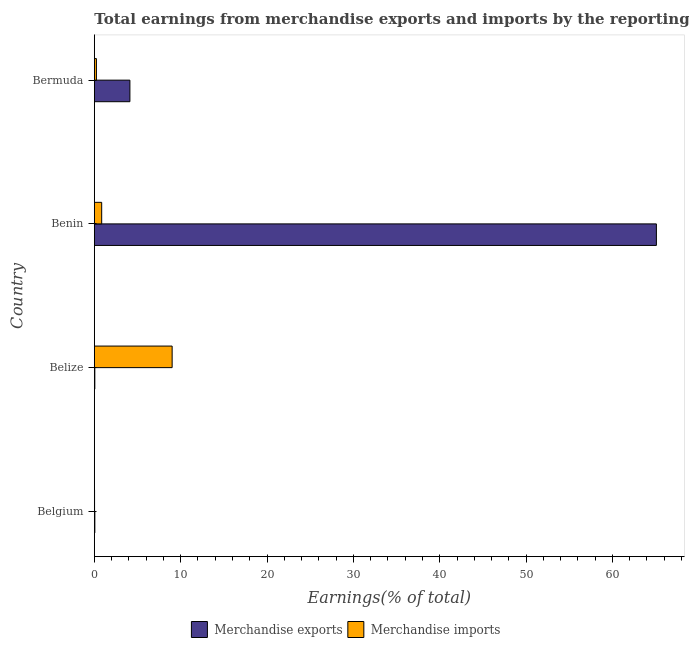How many different coloured bars are there?
Give a very brief answer. 2. How many bars are there on the 4th tick from the top?
Offer a terse response. 2. How many bars are there on the 3rd tick from the bottom?
Offer a terse response. 2. What is the label of the 2nd group of bars from the top?
Give a very brief answer. Benin. What is the earnings from merchandise exports in Benin?
Offer a very short reply. 65.09. Across all countries, what is the maximum earnings from merchandise exports?
Keep it short and to the point. 65.09. Across all countries, what is the minimum earnings from merchandise imports?
Ensure brevity in your answer.  0.03. In which country was the earnings from merchandise imports maximum?
Make the answer very short. Belize. In which country was the earnings from merchandise exports minimum?
Give a very brief answer. Belize. What is the total earnings from merchandise imports in the graph?
Ensure brevity in your answer.  10.13. What is the difference between the earnings from merchandise imports in Belize and that in Bermuda?
Provide a short and direct response. 8.77. What is the difference between the earnings from merchandise imports in Bermuda and the earnings from merchandise exports in Belize?
Make the answer very short. 0.19. What is the average earnings from merchandise exports per country?
Keep it short and to the point. 17.33. What is the difference between the earnings from merchandise imports and earnings from merchandise exports in Benin?
Provide a succinct answer. -64.24. What is the ratio of the earnings from merchandise exports in Belize to that in Bermuda?
Give a very brief answer. 0.01. What is the difference between the highest and the second highest earnings from merchandise exports?
Make the answer very short. 60.97. What is the difference between the highest and the lowest earnings from merchandise imports?
Keep it short and to the point. 8.98. What does the 2nd bar from the top in Benin represents?
Ensure brevity in your answer.  Merchandise exports. How many bars are there?
Make the answer very short. 8. Are all the bars in the graph horizontal?
Offer a very short reply. Yes. How many countries are there in the graph?
Keep it short and to the point. 4. What is the difference between two consecutive major ticks on the X-axis?
Keep it short and to the point. 10. Are the values on the major ticks of X-axis written in scientific E-notation?
Keep it short and to the point. No. Does the graph contain any zero values?
Offer a terse response. No. How many legend labels are there?
Keep it short and to the point. 2. What is the title of the graph?
Offer a very short reply. Total earnings from merchandise exports and imports by the reporting economy(residual) in 2001. Does "Female population" appear as one of the legend labels in the graph?
Your answer should be very brief. No. What is the label or title of the X-axis?
Your answer should be compact. Earnings(% of total). What is the Earnings(% of total) of Merchandise exports in Belgium?
Your response must be concise. 0.06. What is the Earnings(% of total) of Merchandise imports in Belgium?
Offer a terse response. 0.03. What is the Earnings(% of total) of Merchandise exports in Belize?
Provide a short and direct response. 0.06. What is the Earnings(% of total) of Merchandise imports in Belize?
Offer a very short reply. 9.01. What is the Earnings(% of total) of Merchandise exports in Benin?
Provide a succinct answer. 65.09. What is the Earnings(% of total) in Merchandise imports in Benin?
Ensure brevity in your answer.  0.85. What is the Earnings(% of total) of Merchandise exports in Bermuda?
Ensure brevity in your answer.  4.12. What is the Earnings(% of total) of Merchandise imports in Bermuda?
Keep it short and to the point. 0.24. Across all countries, what is the maximum Earnings(% of total) in Merchandise exports?
Your answer should be very brief. 65.09. Across all countries, what is the maximum Earnings(% of total) of Merchandise imports?
Keep it short and to the point. 9.01. Across all countries, what is the minimum Earnings(% of total) of Merchandise exports?
Your answer should be very brief. 0.06. Across all countries, what is the minimum Earnings(% of total) in Merchandise imports?
Give a very brief answer. 0.03. What is the total Earnings(% of total) in Merchandise exports in the graph?
Your answer should be compact. 69.32. What is the total Earnings(% of total) in Merchandise imports in the graph?
Your response must be concise. 10.13. What is the difference between the Earnings(% of total) of Merchandise exports in Belgium and that in Belize?
Your answer should be very brief. 0. What is the difference between the Earnings(% of total) in Merchandise imports in Belgium and that in Belize?
Offer a terse response. -8.98. What is the difference between the Earnings(% of total) of Merchandise exports in Belgium and that in Benin?
Your answer should be compact. -65.03. What is the difference between the Earnings(% of total) of Merchandise imports in Belgium and that in Benin?
Ensure brevity in your answer.  -0.82. What is the difference between the Earnings(% of total) in Merchandise exports in Belgium and that in Bermuda?
Your response must be concise. -4.06. What is the difference between the Earnings(% of total) of Merchandise imports in Belgium and that in Bermuda?
Provide a short and direct response. -0.22. What is the difference between the Earnings(% of total) of Merchandise exports in Belize and that in Benin?
Keep it short and to the point. -65.03. What is the difference between the Earnings(% of total) in Merchandise imports in Belize and that in Benin?
Keep it short and to the point. 8.16. What is the difference between the Earnings(% of total) in Merchandise exports in Belize and that in Bermuda?
Your answer should be compact. -4.06. What is the difference between the Earnings(% of total) in Merchandise imports in Belize and that in Bermuda?
Provide a succinct answer. 8.77. What is the difference between the Earnings(% of total) in Merchandise exports in Benin and that in Bermuda?
Offer a terse response. 60.97. What is the difference between the Earnings(% of total) of Merchandise imports in Benin and that in Bermuda?
Your answer should be very brief. 0.61. What is the difference between the Earnings(% of total) in Merchandise exports in Belgium and the Earnings(% of total) in Merchandise imports in Belize?
Provide a short and direct response. -8.95. What is the difference between the Earnings(% of total) in Merchandise exports in Belgium and the Earnings(% of total) in Merchandise imports in Benin?
Ensure brevity in your answer.  -0.79. What is the difference between the Earnings(% of total) in Merchandise exports in Belgium and the Earnings(% of total) in Merchandise imports in Bermuda?
Your answer should be very brief. -0.18. What is the difference between the Earnings(% of total) in Merchandise exports in Belize and the Earnings(% of total) in Merchandise imports in Benin?
Offer a terse response. -0.79. What is the difference between the Earnings(% of total) in Merchandise exports in Belize and the Earnings(% of total) in Merchandise imports in Bermuda?
Offer a terse response. -0.19. What is the difference between the Earnings(% of total) of Merchandise exports in Benin and the Earnings(% of total) of Merchandise imports in Bermuda?
Offer a terse response. 64.85. What is the average Earnings(% of total) in Merchandise exports per country?
Give a very brief answer. 17.33. What is the average Earnings(% of total) in Merchandise imports per country?
Give a very brief answer. 2.53. What is the difference between the Earnings(% of total) of Merchandise exports and Earnings(% of total) of Merchandise imports in Belgium?
Ensure brevity in your answer.  0.03. What is the difference between the Earnings(% of total) in Merchandise exports and Earnings(% of total) in Merchandise imports in Belize?
Provide a short and direct response. -8.95. What is the difference between the Earnings(% of total) of Merchandise exports and Earnings(% of total) of Merchandise imports in Benin?
Offer a very short reply. 64.24. What is the difference between the Earnings(% of total) in Merchandise exports and Earnings(% of total) in Merchandise imports in Bermuda?
Provide a short and direct response. 3.88. What is the ratio of the Earnings(% of total) of Merchandise exports in Belgium to that in Belize?
Provide a short and direct response. 1.03. What is the ratio of the Earnings(% of total) of Merchandise imports in Belgium to that in Belize?
Your response must be concise. 0. What is the ratio of the Earnings(% of total) of Merchandise exports in Belgium to that in Benin?
Your answer should be compact. 0. What is the ratio of the Earnings(% of total) of Merchandise imports in Belgium to that in Benin?
Provide a short and direct response. 0.03. What is the ratio of the Earnings(% of total) in Merchandise exports in Belgium to that in Bermuda?
Ensure brevity in your answer.  0.01. What is the ratio of the Earnings(% of total) in Merchandise imports in Belgium to that in Bermuda?
Your response must be concise. 0.11. What is the ratio of the Earnings(% of total) in Merchandise exports in Belize to that in Benin?
Provide a succinct answer. 0. What is the ratio of the Earnings(% of total) of Merchandise imports in Belize to that in Benin?
Your answer should be compact. 10.59. What is the ratio of the Earnings(% of total) in Merchandise exports in Belize to that in Bermuda?
Give a very brief answer. 0.01. What is the ratio of the Earnings(% of total) of Merchandise imports in Belize to that in Bermuda?
Keep it short and to the point. 37.19. What is the ratio of the Earnings(% of total) in Merchandise exports in Benin to that in Bermuda?
Keep it short and to the point. 15.8. What is the ratio of the Earnings(% of total) of Merchandise imports in Benin to that in Bermuda?
Offer a very short reply. 3.51. What is the difference between the highest and the second highest Earnings(% of total) in Merchandise exports?
Ensure brevity in your answer.  60.97. What is the difference between the highest and the second highest Earnings(% of total) of Merchandise imports?
Your answer should be compact. 8.16. What is the difference between the highest and the lowest Earnings(% of total) in Merchandise exports?
Your response must be concise. 65.03. What is the difference between the highest and the lowest Earnings(% of total) of Merchandise imports?
Offer a terse response. 8.98. 